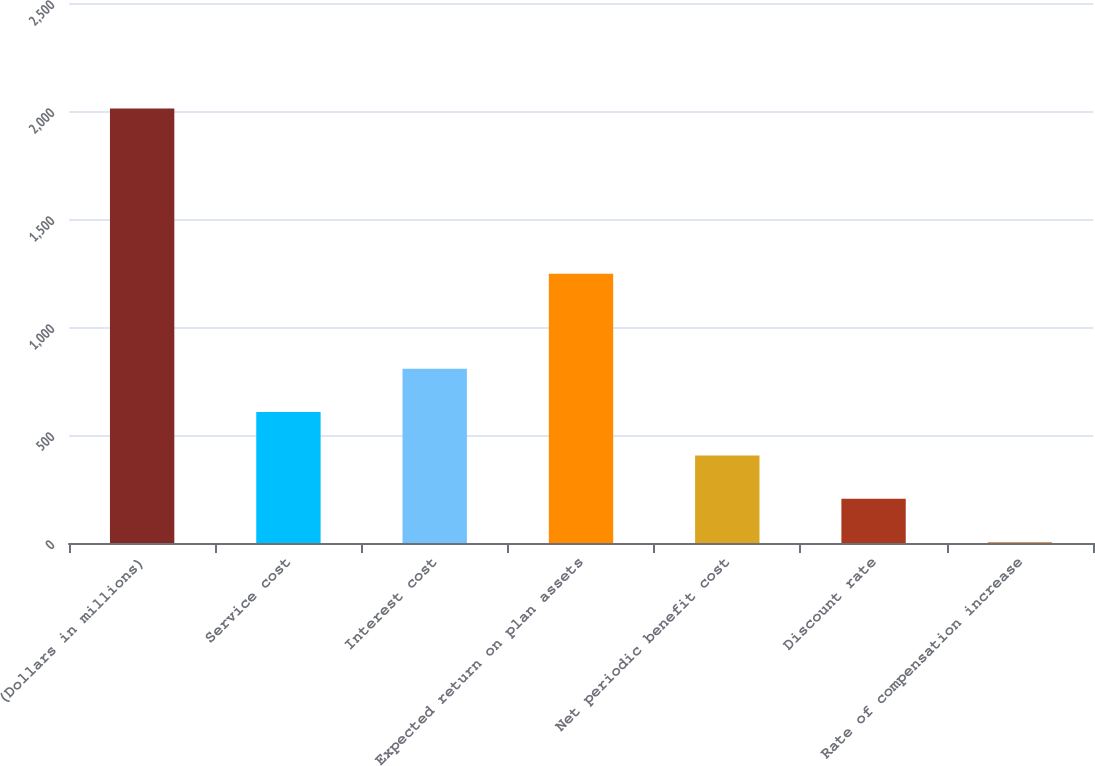<chart> <loc_0><loc_0><loc_500><loc_500><bar_chart><fcel>(Dollars in millions)<fcel>Service cost<fcel>Interest cost<fcel>Expected return on plan assets<fcel>Net periodic benefit cost<fcel>Discount rate<fcel>Rate of compensation increase<nl><fcel>2012<fcel>606.4<fcel>807.2<fcel>1246<fcel>405.6<fcel>204.8<fcel>4<nl></chart> 